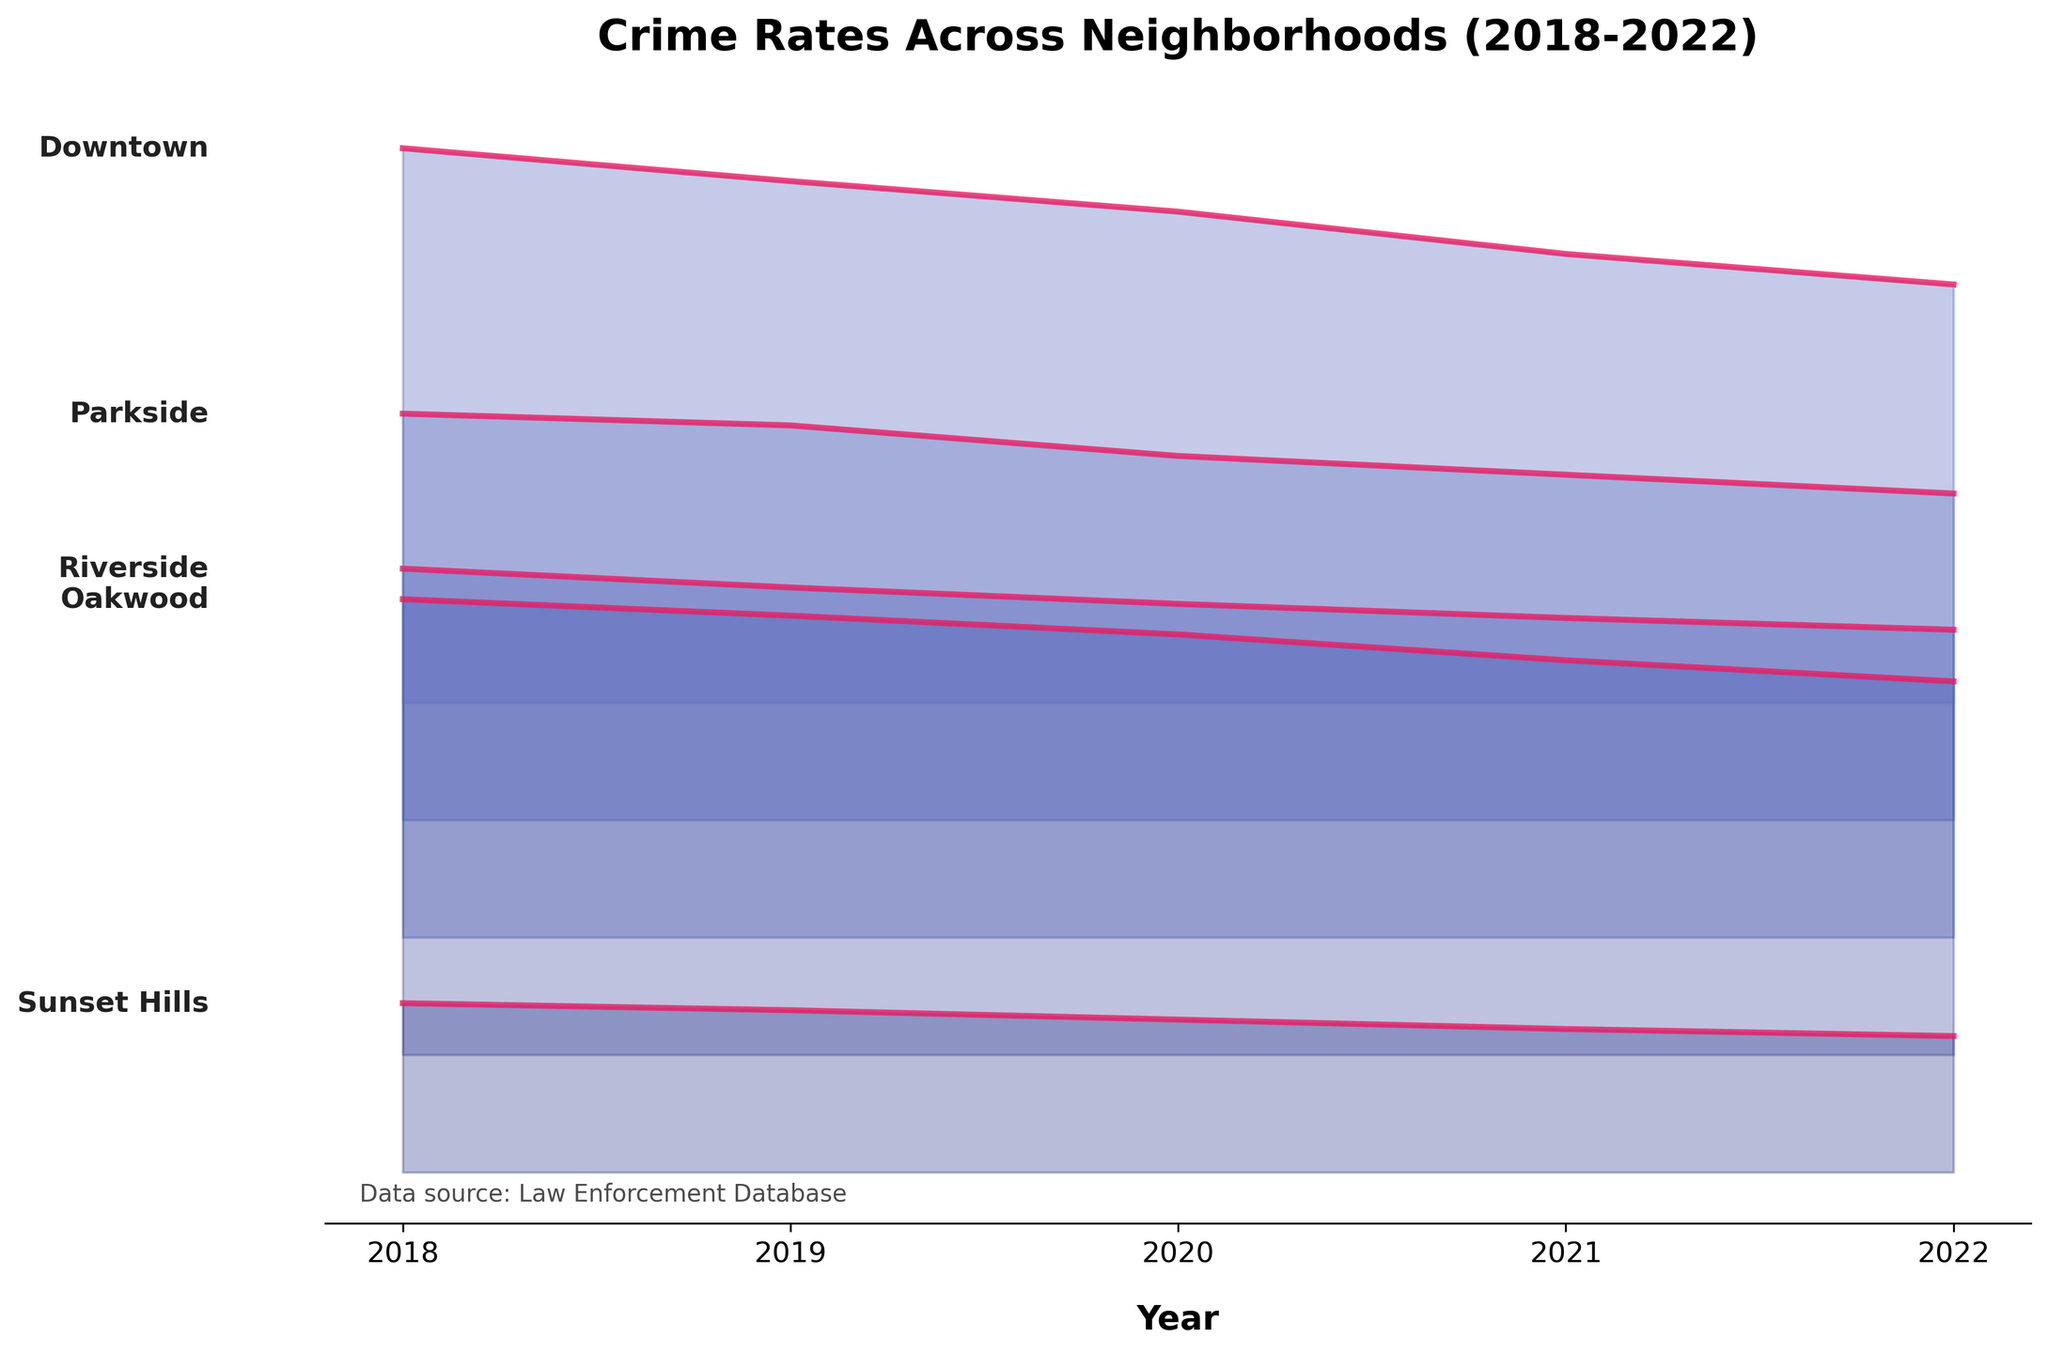What's the title of the figure? The title is usually displayed at the top of the plot. This specific plot's title is "Crime Rates Across Neighborhoods (2018-2022)".
Answer: Crime Rates Across Neighborhoods (2018-2022) What do the colors in the figure represent? Based on the visual trend and the accompanying details, different colors are used to represent different neighborhoods.
Answer: Different neighborhoods How many neighborhoods are compared in the figure? By counting the lines or labels present on the plot, we can deduce that there are five neighborhoods represented.
Answer: Five Which neighborhood had the highest crime rate in 2018? Referring to the plot where all neighborhoods' crime rates for 2018 are compared, Downtown has the highest value.
Answer: Downtown Has the crime rate in Sunset Hills increased or decreased over the 5-year period? Observing the trend of the line representing Sunset Hills from 2018 to 2022, it's clear that the crime rate has consistently declined.
Answer: Decreased What was the crime rate in Oakwood in 2020? By locating the line for Oakwood and following it to the point marked for 2020, we can read the crime rate.
Answer: 17.9 Which neighborhood showed the most significant decrease in crime rate over the entire period? Comparing the starting and ending points of each neighborhood's line, Downtown shows the most significant decline from 28.6 in 2018 to 22.8 in 2022.
Answer: Downtown Which neighborhoods had a crime rate below 10 in 2022? By checking the values at 2022 for each neighborhood, Parkside and Sunset Hills both show values below 10.
Answer: Parkside and Sunset Hills How does the crime rate in Riverside in 2021 compare to that in 2018? Referencing Riverside's values for both years, 2021's crime rate is lower at 13.6 compared to 15.7 in 2018.
Answer: Lower in 2021 Is there any neighborhood where the crime rate remained the same over the 5 years? Observing the trends, it's clear that all neighborhoods show a decline, and none have a static crime rate.
Answer: No Which year had the lowest overall crime rate across all neighborhoods? By finding the common trend across all neighborhood values, 2022 has the lowest crime rates overall compared to other years.
Answer: 2022 